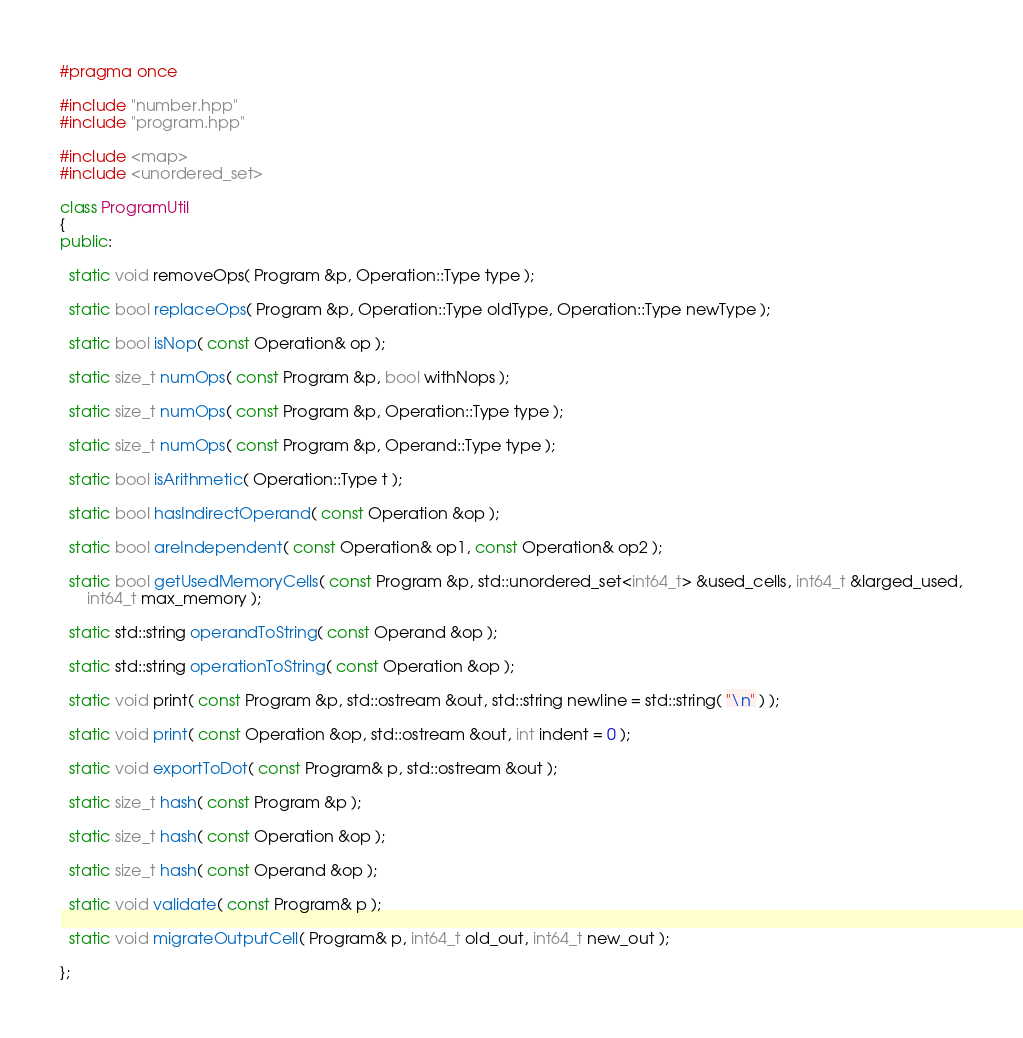<code> <loc_0><loc_0><loc_500><loc_500><_C++_>#pragma once

#include "number.hpp"
#include "program.hpp"

#include <map>
#include <unordered_set>

class ProgramUtil
{
public:

  static void removeOps( Program &p, Operation::Type type );

  static bool replaceOps( Program &p, Operation::Type oldType, Operation::Type newType );

  static bool isNop( const Operation& op );

  static size_t numOps( const Program &p, bool withNops );

  static size_t numOps( const Program &p, Operation::Type type );

  static size_t numOps( const Program &p, Operand::Type type );

  static bool isArithmetic( Operation::Type t );

  static bool hasIndirectOperand( const Operation &op );

  static bool areIndependent( const Operation& op1, const Operation& op2 );

  static bool getUsedMemoryCells( const Program &p, std::unordered_set<int64_t> &used_cells, int64_t &larged_used,
      int64_t max_memory );

  static std::string operandToString( const Operand &op );

  static std::string operationToString( const Operation &op );

  static void print( const Program &p, std::ostream &out, std::string newline = std::string( "\n" ) );

  static void print( const Operation &op, std::ostream &out, int indent = 0 );

  static void exportToDot( const Program& p, std::ostream &out );

  static size_t hash( const Program &p );

  static size_t hash( const Operation &op );

  static size_t hash( const Operand &op );

  static void validate( const Program& p );

  static void migrateOutputCell( Program& p, int64_t old_out, int64_t new_out );

};
</code> 